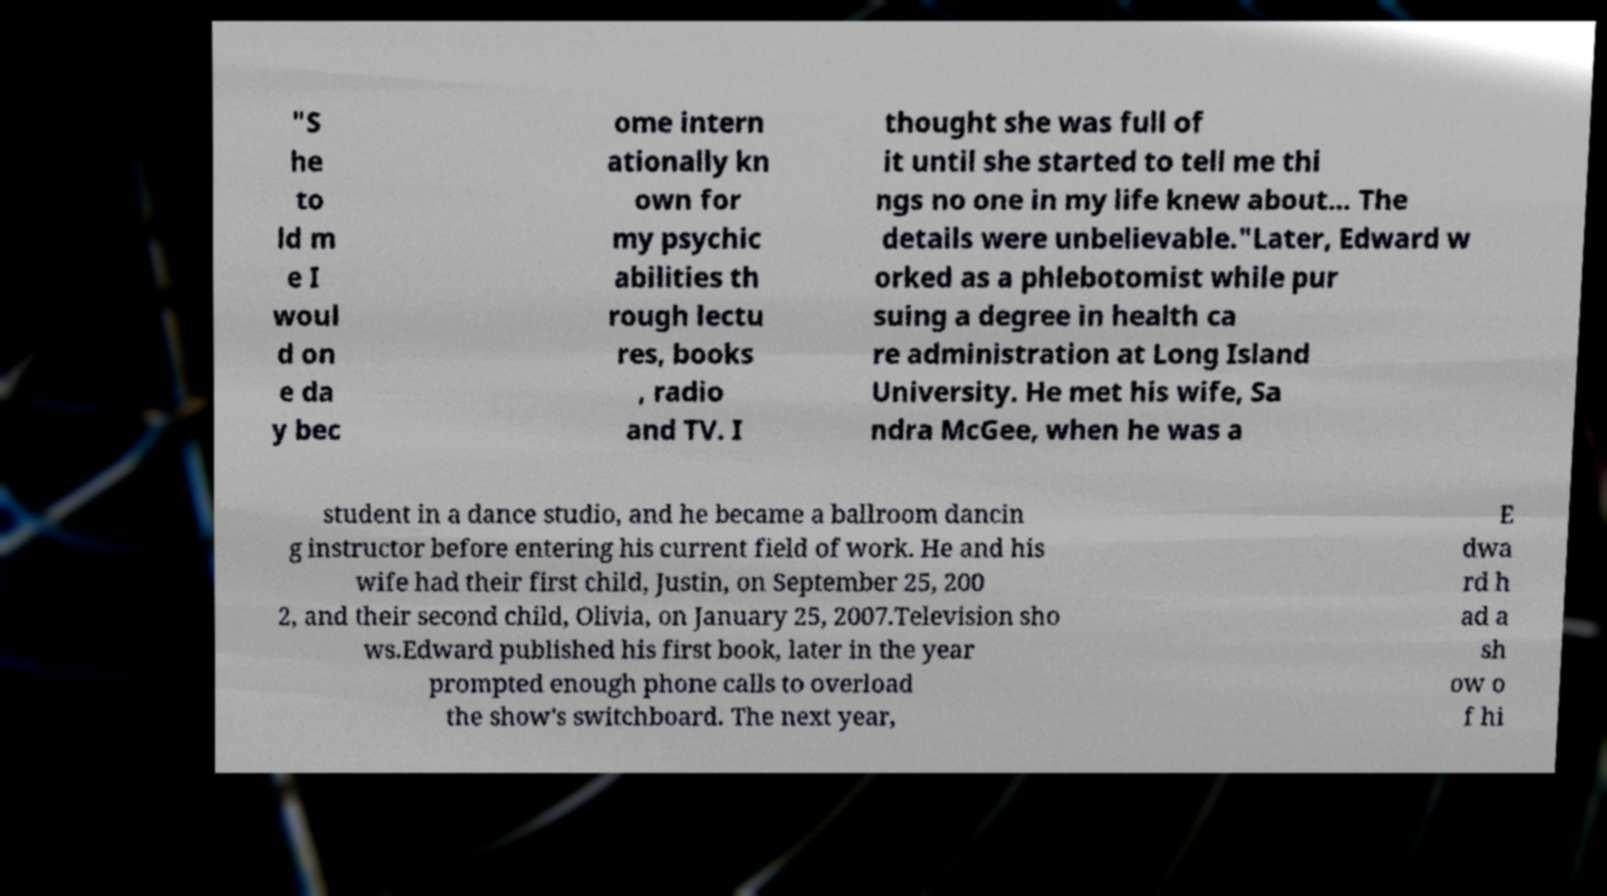I need the written content from this picture converted into text. Can you do that? "S he to ld m e I woul d on e da y bec ome intern ationally kn own for my psychic abilities th rough lectu res, books , radio and TV. I thought she was full of it until she started to tell me thi ngs no one in my life knew about... The details were unbelievable."Later, Edward w orked as a phlebotomist while pur suing a degree in health ca re administration at Long Island University. He met his wife, Sa ndra McGee, when he was a student in a dance studio, and he became a ballroom dancin g instructor before entering his current field of work. He and his wife had their first child, Justin, on September 25, 200 2, and their second child, Olivia, on January 25, 2007.Television sho ws.Edward published his first book, later in the year prompted enough phone calls to overload the show's switchboard. The next year, E dwa rd h ad a sh ow o f hi 